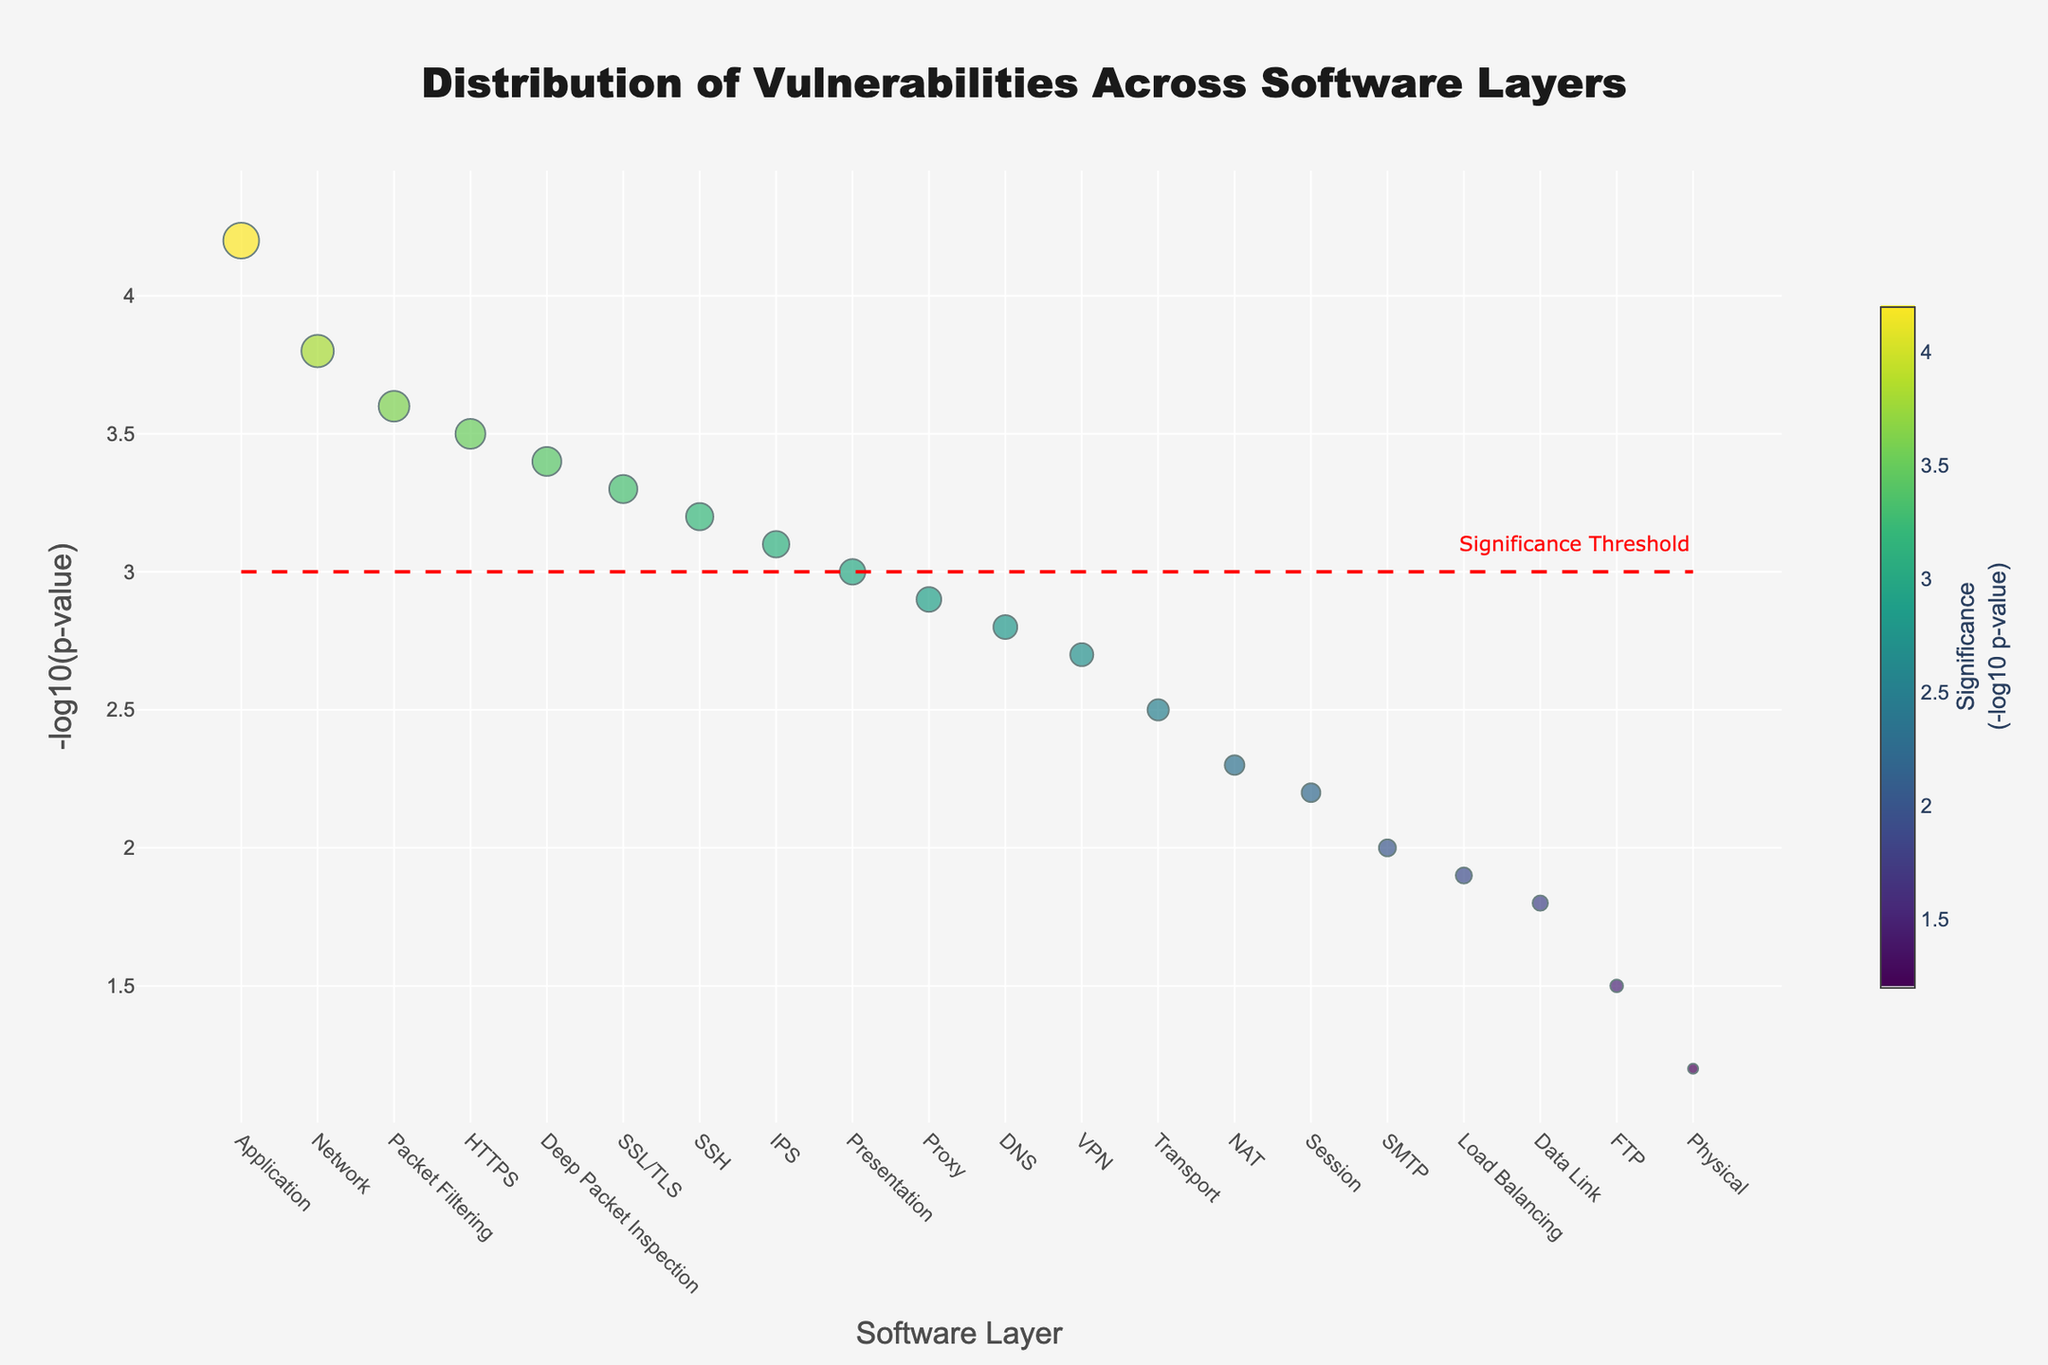what is the title of the plot? The title is written at the top of the figure in a larger, bold font. It provides an overview of what the plot represents.
Answer: Distribution of Vulnerabilities Across Software Layers What layer has the highest significance value? The layer with the highest -log10(p-value) appears at the top of the plot. They are sorted in descending order from left to right based on the -log10(p-value).
Answer: Application How many layers have a significance value above the threshold line? The red dashed line at y=3 represents the significance threshold. Counting the points above this line will give the number of layers above the threshold.
Answer: 11 Which layer has the smallest -log10(p-value)? The smallest -log10(p-value) will be the lowest value on the y-axis of the plot. Identify the label at this low point.
Answer: Physical What is the total number of vulnerabilities at the Application and Network layers? Sum the numbers of vulnerabilities, which are given for each point when hovered over, for the Application and Network layers.
Answer: 42 + 38 = 80 Which layer between HTTPS and DNS has a higher -log10(p-value)? Compare the -log10(p-value) values for HTTPS and DNS on the y-axis of the plot.
Answer: HTTPS Identify all layers that fall below the significance threshold. Any points that fall below the red dashed threshold line (y=3) need to be counted and listed.
Answer: Data Link, Physical, Session, SMTP, FTP, Load Balancing What color represents the highest significance value? The color scale is shown on the right side of the plot, so the color associated with the highest -log10(p-value) can be identified there.
Answer: Bright yellow Compare the number of vulnerabilities at the Presentation and Proxy layers. Which one has more? Look at the size of the markers (or hover over them) at the Presentation and Proxy layers to determine the number of vulnerabilities.
Answer: Presentation How many data points are there in total in this plot? Count the number of distinct markers in the plot to find the total number of data points.
Answer: 20 